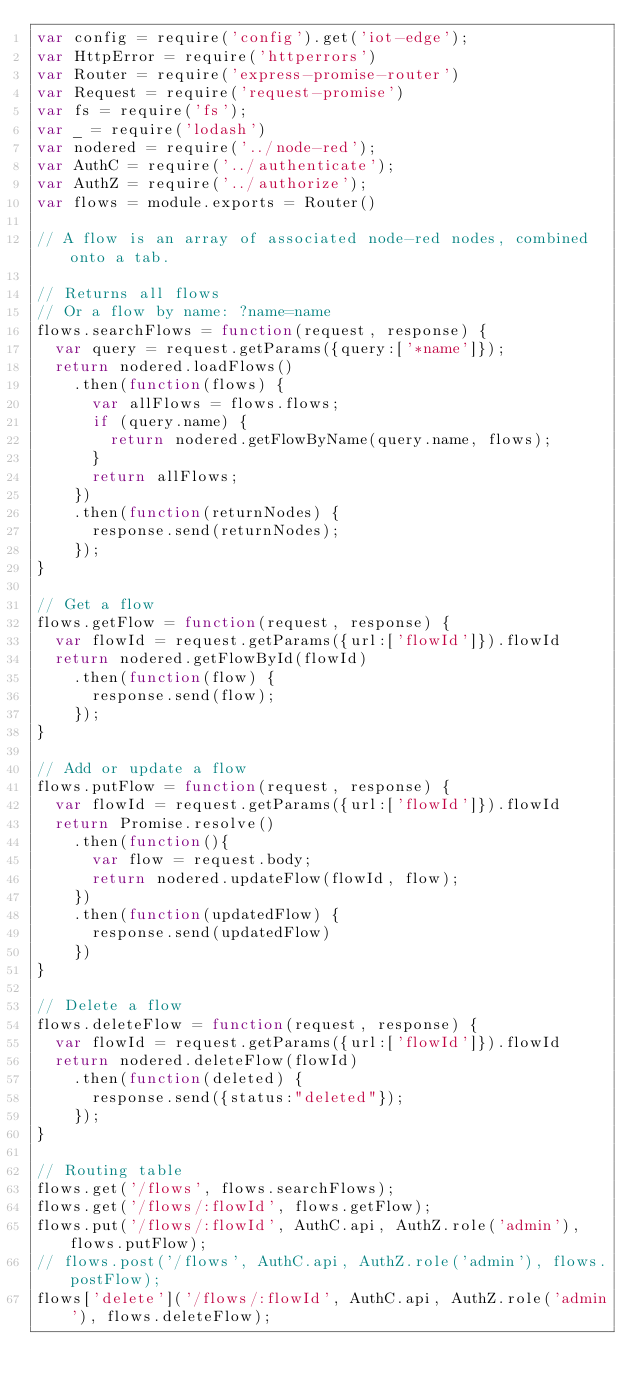<code> <loc_0><loc_0><loc_500><loc_500><_JavaScript_>var config = require('config').get('iot-edge');
var HttpError = require('httperrors')
var Router = require('express-promise-router')
var Request = require('request-promise')
var fs = require('fs');
var _ = require('lodash')
var nodered = require('../node-red');
var AuthC = require('../authenticate');
var AuthZ = require('../authorize');
var flows = module.exports = Router()

// A flow is an array of associated node-red nodes, combined onto a tab.

// Returns all flows
// Or a flow by name: ?name=name
flows.searchFlows = function(request, response) {
  var query = request.getParams({query:['*name']});
  return nodered.loadFlows()
    .then(function(flows) {
      var allFlows = flows.flows;
      if (query.name) {
        return nodered.getFlowByName(query.name, flows);
      }
      return allFlows;
    })
    .then(function(returnNodes) {
      response.send(returnNodes);
    });
}

// Get a flow
flows.getFlow = function(request, response) {
  var flowId = request.getParams({url:['flowId']}).flowId
  return nodered.getFlowById(flowId)
    .then(function(flow) {
      response.send(flow);
    });
}

// Add or update a flow
flows.putFlow = function(request, response) {
  var flowId = request.getParams({url:['flowId']}).flowId
  return Promise.resolve()
    .then(function(){
      var flow = request.body;
      return nodered.updateFlow(flowId, flow);
    })
    .then(function(updatedFlow) {
      response.send(updatedFlow)
    })
}

// Delete a flow
flows.deleteFlow = function(request, response) {
  var flowId = request.getParams({url:['flowId']}).flowId
  return nodered.deleteFlow(flowId)
    .then(function(deleted) {
      response.send({status:"deleted"});
    });
}

// Routing table
flows.get('/flows', flows.searchFlows);
flows.get('/flows/:flowId', flows.getFlow);
flows.put('/flows/:flowId', AuthC.api, AuthZ.role('admin'), flows.putFlow);
// flows.post('/flows', AuthC.api, AuthZ.role('admin'), flows.postFlow);
flows['delete']('/flows/:flowId', AuthC.api, AuthZ.role('admin'), flows.deleteFlow);
</code> 